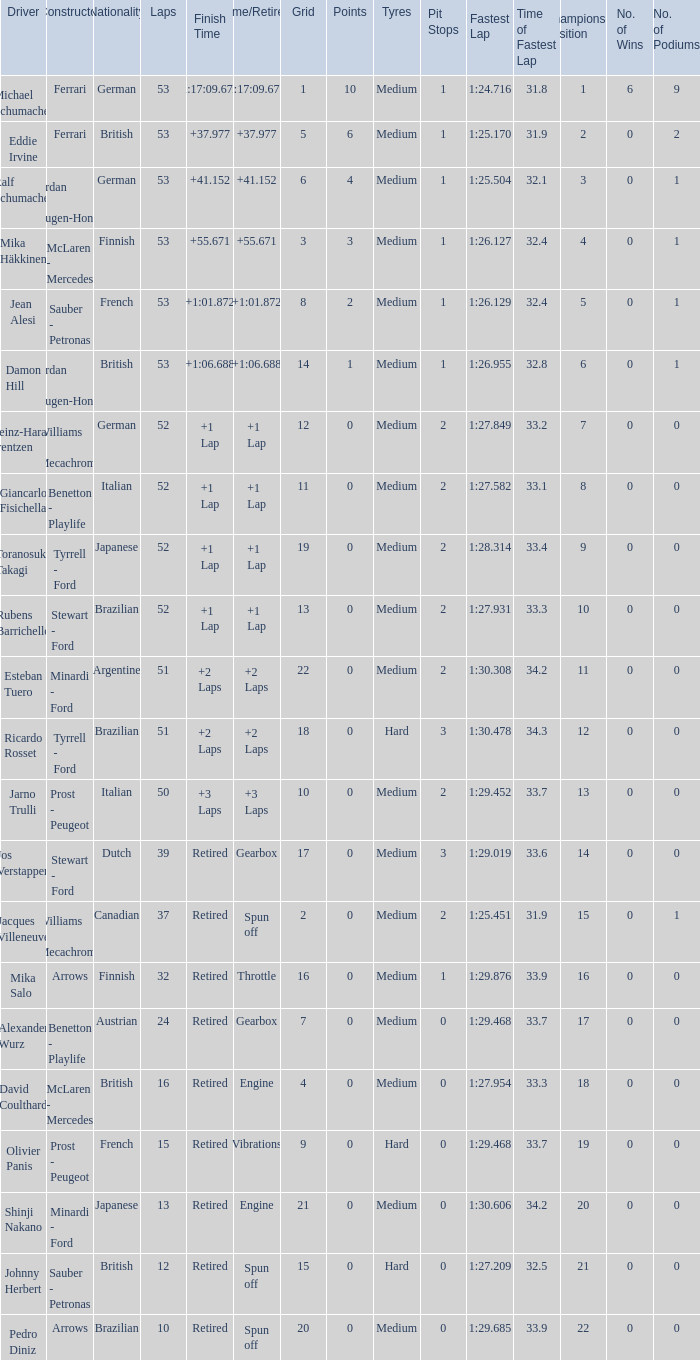What is the grid total for ralf schumacher racing over 53 laps? None. 